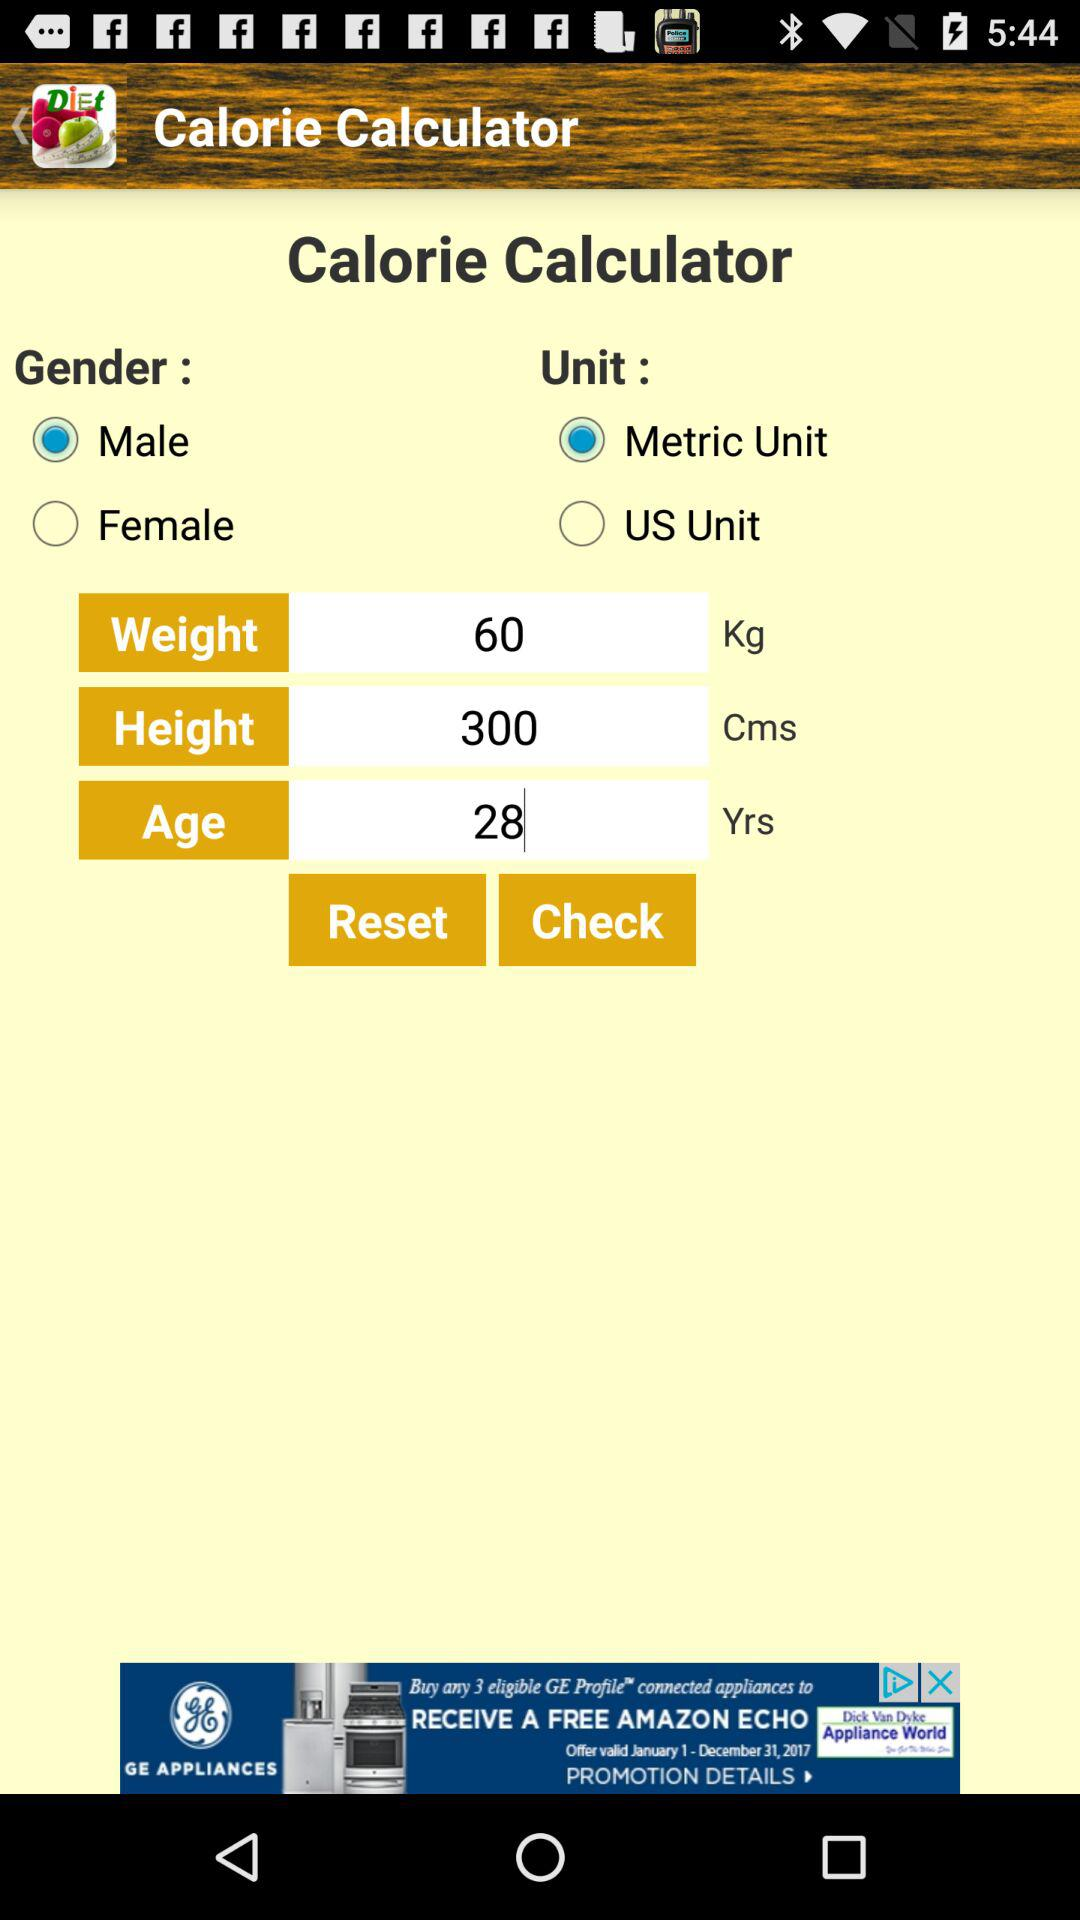How many options are there to choose from for the Gender field?
Answer the question using a single word or phrase. 2 